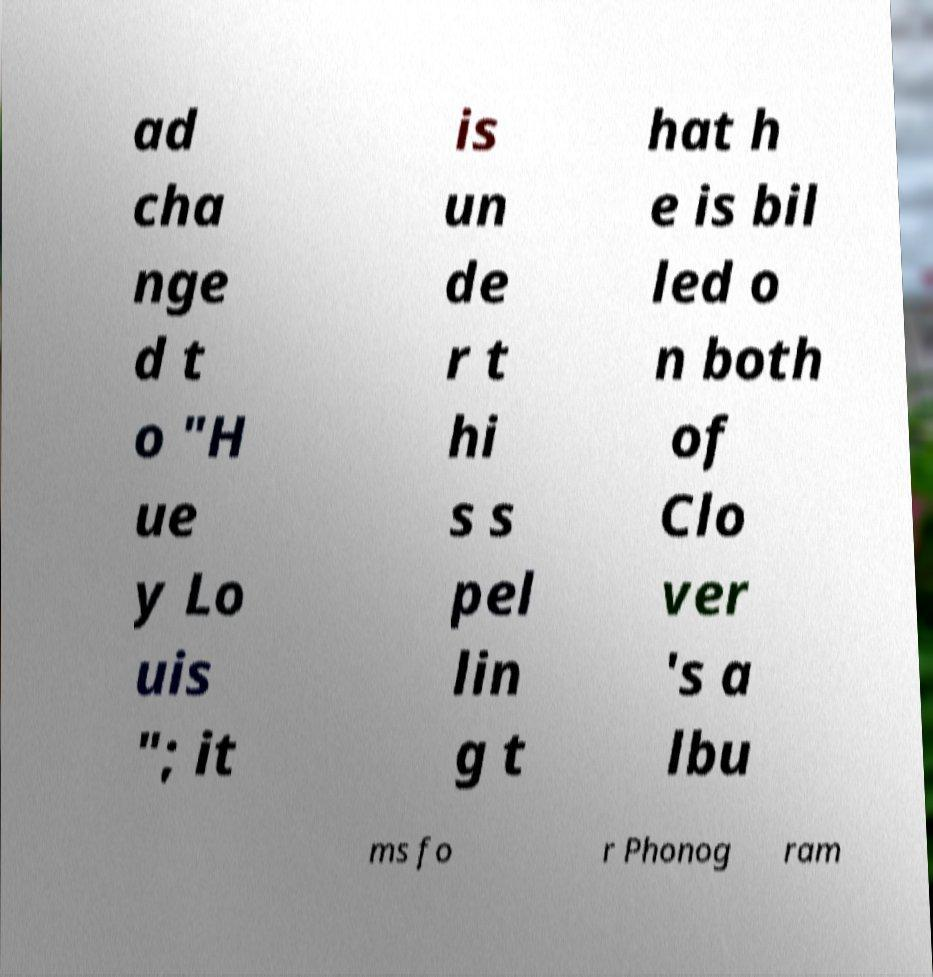Could you assist in decoding the text presented in this image and type it out clearly? ad cha nge d t o "H ue y Lo uis "; it is un de r t hi s s pel lin g t hat h e is bil led o n both of Clo ver 's a lbu ms fo r Phonog ram 